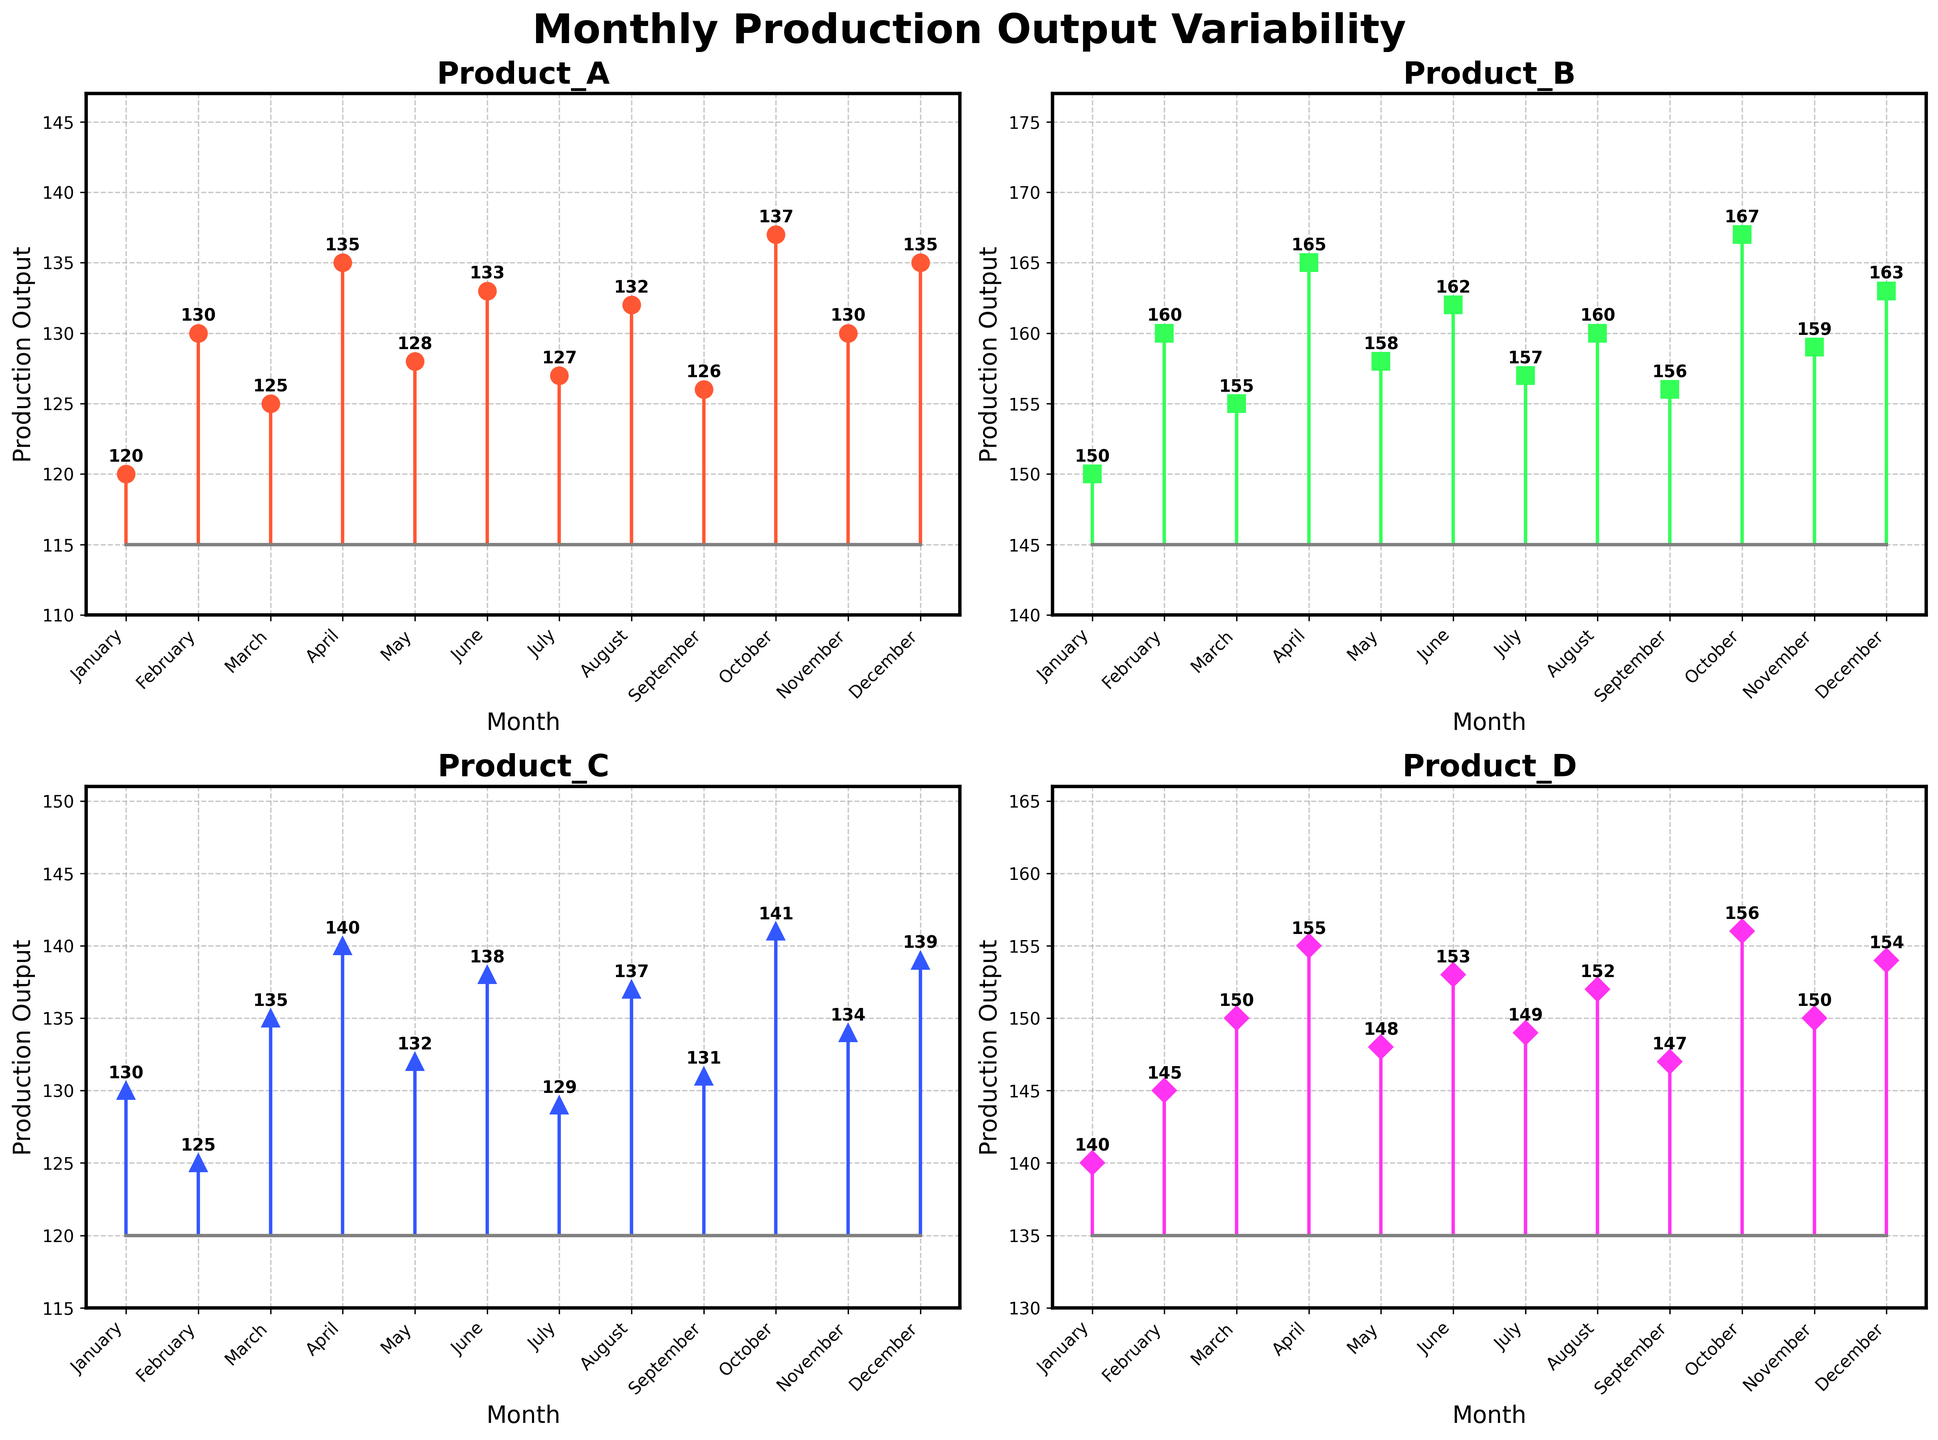What is the title of the figure? The title is written at the top of the figure in bold letters. It reads "Monthly Production Output Variability".
Answer: Monthly Production Output Variability What is the production output for Product_A in March? Locate the subplot for Product_A and find the value marked with 'March'. The value annotated is 125.
Answer: 125 Which product has the highest output in October? Look at each subplot for the month of October. Product_B has an output value of 167, which is the highest among the products.
Answer: Product_B What is the average output of Product_C in the first quarter (January to March)? Find the outputs for Product_C in January, February, and March. Sum these values and then divide by 3. The sum is 130 + 125 + 135 = 390. So, the average is 390/3 = 130.
Answer: 130 How does the output of Product_D in November compare to that in December? Compare the values for Product_D in November (150) and December (154). December's value is higher than November's.
Answer: December is higher Which month has the lowest production output for Product_B? Examine the subplot for Product_B and identify the month with the smallest value. The month with the lowest value is January, with an output of 150.
Answer: January Do any of the products have the same output in two different months? Check each subplot's values for repetitions. Product_B has the same output of 160 in February and August.
Answer: Product_B What is the total production output for Product_A over all the months? Sum the monthly production outputs for Product_A across all months, which is 120 + 130 + 125 + 135 + 128 + 133 + 127 + 132 + 126 + 137 + 130 + 135 = 1558.
Answer: 1558 How much does Product_C's output vary from the highest to the lowest month? Check Product_C’s highest (141 in October) and lowest (125 in February) output. The difference is 141 - 125 = 16.
Answer: 16 